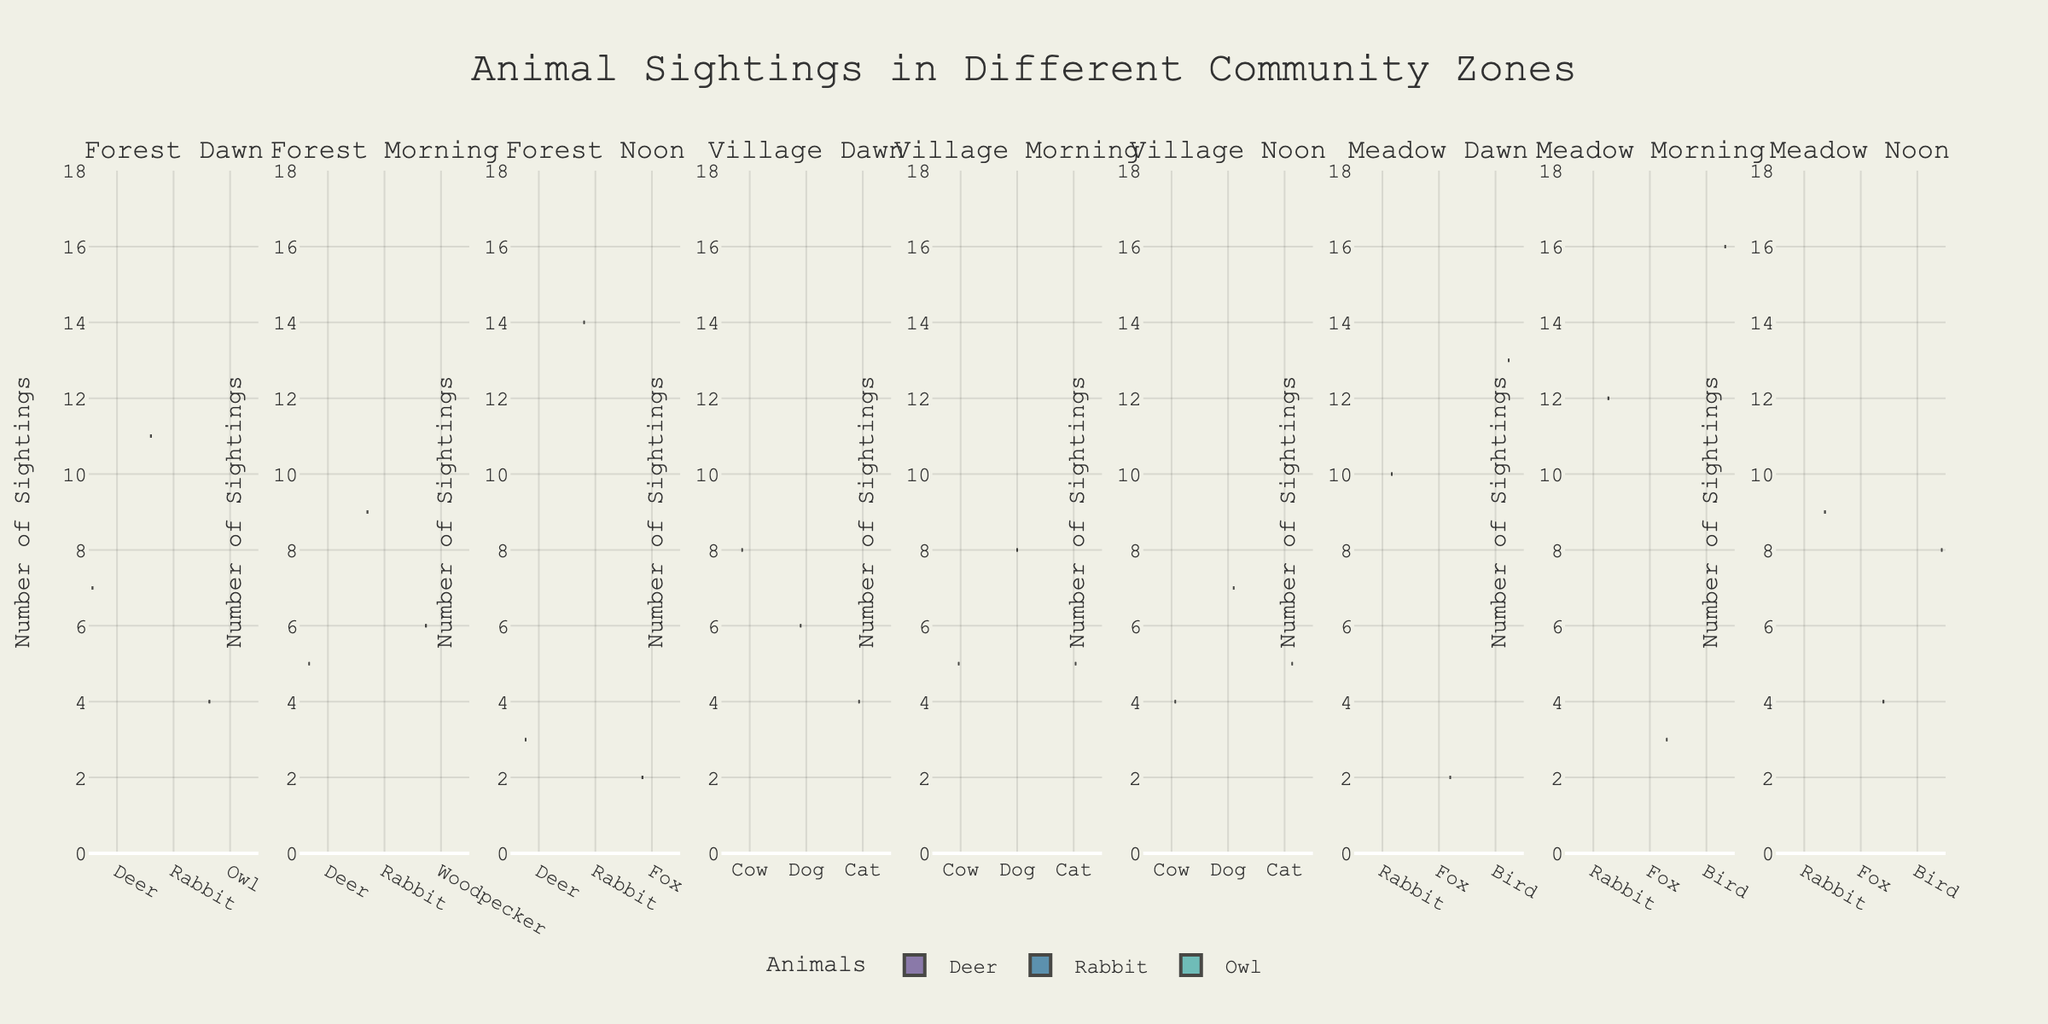What is the title of the figure? The title of the figure is often located at the top center. It provides a summary of what the figure represents.
Answer: Animal Sightings in Different Community Zones Which animal was seen the most in the Forest zone during different times of the day? By examining the heights and densities of the violins in the Forest zone subplot, you can determine which animal has the highest maximum value of sightings.
Answer: Rabbit How do the sighting frequencies of Deer in the Forest zone at dawn compare to those at noon? Look at the violins for Deer in the Forest zone at the different times of day and compare the distributions.
Answer: More at dawn What's the range of Rabbit sightings in the Meadow during the morning? Identify the violin plot for Rabbit sightings in the Meadow during the morning. Observe the spread from the minimum to the maximum value.
Answer: 12 to 16 Which zone had the least number of Fox sightings overall? Compare the number of Fox sightings across all zones by examining the violins. The zone with the least density and height will be the answer.
Answer: Village What's the average number of Bird sightings in the Meadow across all times of the day? Identify the Bird violins in the Meadow subplot and calculate the average of their values by summing the values and dividing by the number of time points.
Answer: (13+16+8)/3 = ~12.33 Compare the sighting patterns for Rabbits in the Forest and Meadow zones. Which zone shows a higher variation in sightings? Examine the spread (width) of the Rabbit violins in the Forest and Meadow subplots to identify which has higher variation.
Answer: Meadow Which time of day generally has the highest number of animal sightings in the Village zone? By observing the maximum heights of the violins for each time of day in the Village zone subplot, determine the time with the highest overall sightings.
Answer: Dawn Is there any animal that appears consistently across all zones? Look through the violins in each zone and identify any animal that is represented in every subplot.
Answer: Rabbit What is the median number of sighting reports for the Owl in the Forest zone at dawn? Identify the Owl violin in the Forest zone at dawn. Look for the median line (usually a central thicker line) to determine the median sightings.
Answer: 4 